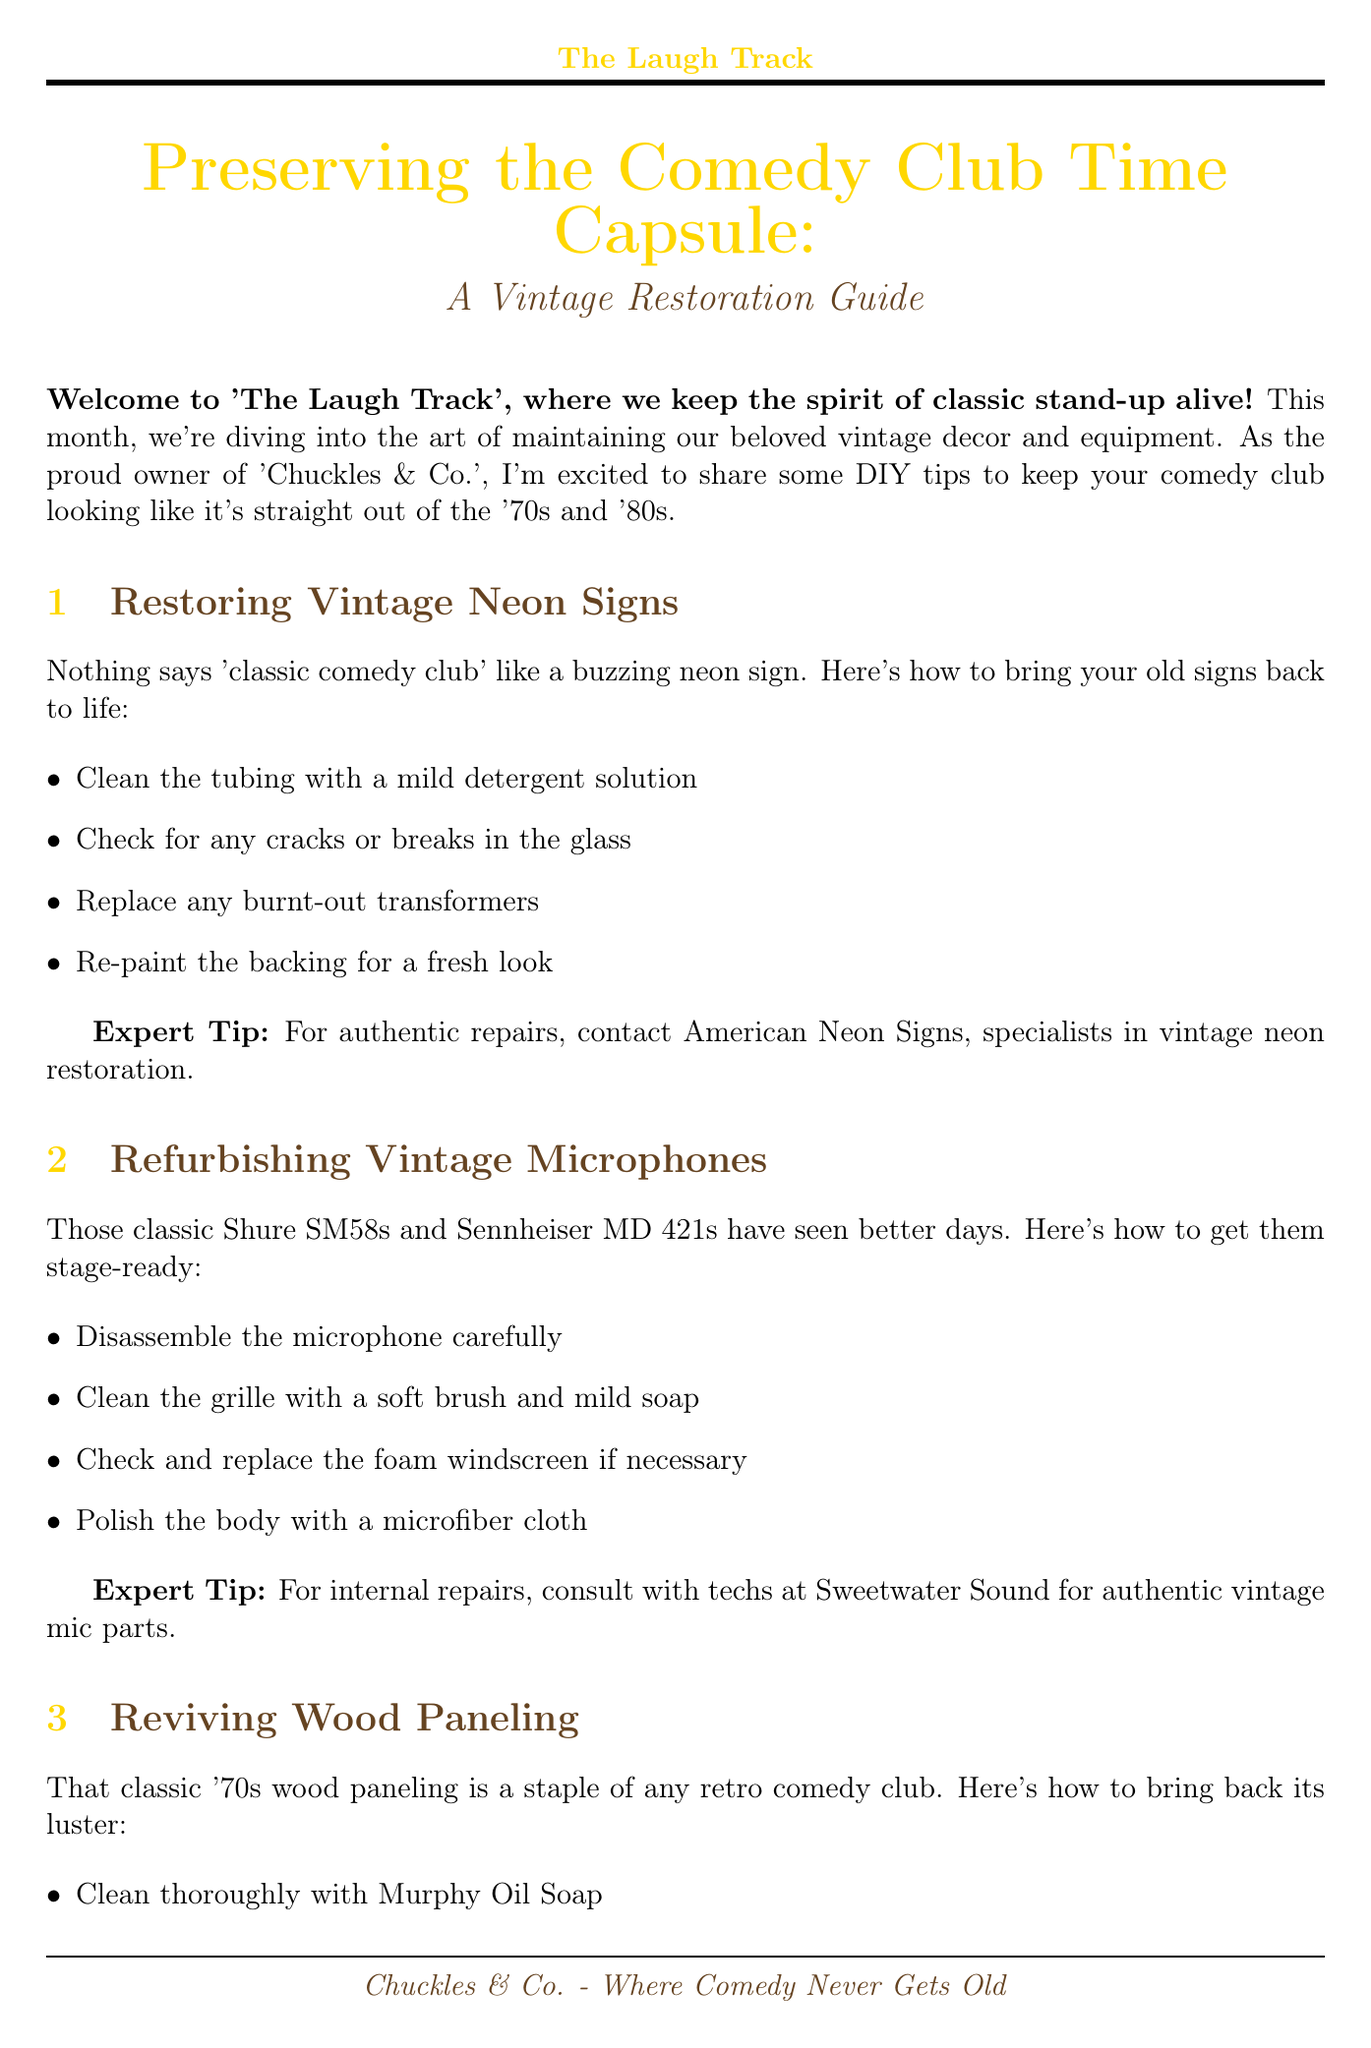What is the title of the newsletter? The title of the newsletter is specified in the document as the main heading.
Answer: Preserving the Comedy Club Time Capsule: A Vintage Restoration Guide How many sections does the newsletter have? The number of sections is determined by counting the individual topics outlined in the sections part of the document.
Answer: Four Which expert is recommended for vintage neon sign restoration? The expert recommendation is included in the expert tip section of the neon signs restoration instructions.
Answer: American Neon Signs What is the cleaning product suggested for wood paneling? The document specifies the cleaning product recommended for wood paneling within its instructions.
Answer: Murphy Oil Soap What is the first step for restoring vintage microphones? The first step is mentioned in the refurbishment section for vintage microphones.
Answer: Disassemble the microphone carefully Name one vintage sound equipment brand mentioned. The document lists specific brands of sound equipment, which can be identified in the maintenance section.
Answer: Peavey What type of event is promoted at the end of the document? The promotional event is described in the call-to-action section, where it says what's happening at the club.
Answer: Retro Roast 